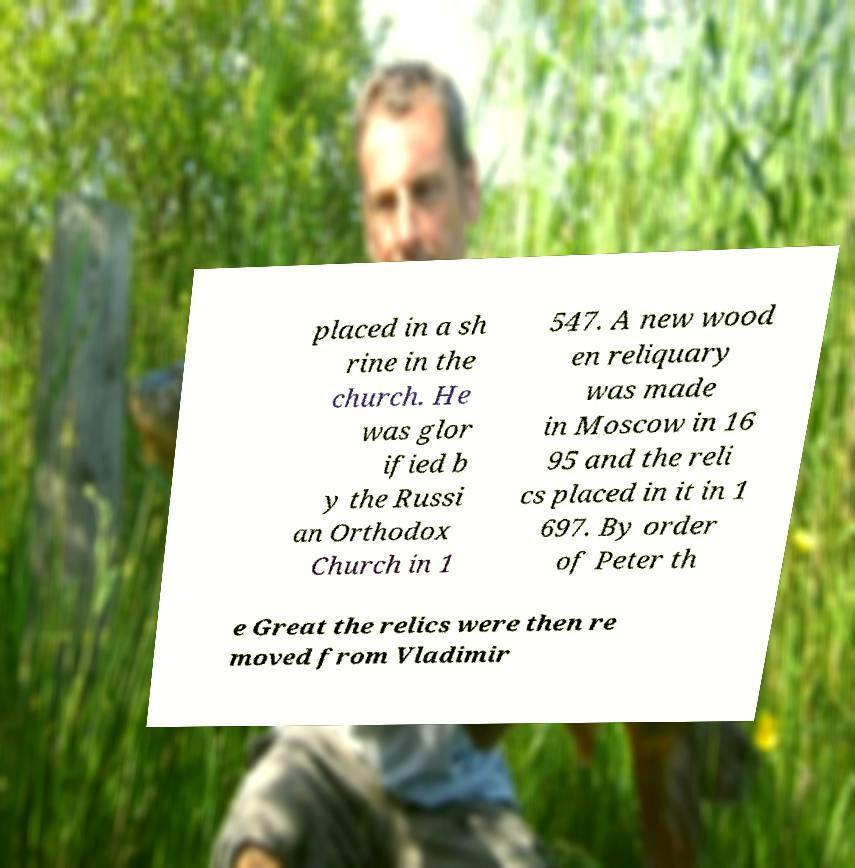There's text embedded in this image that I need extracted. Can you transcribe it verbatim? placed in a sh rine in the church. He was glor ified b y the Russi an Orthodox Church in 1 547. A new wood en reliquary was made in Moscow in 16 95 and the reli cs placed in it in 1 697. By order of Peter th e Great the relics were then re moved from Vladimir 